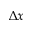<formula> <loc_0><loc_0><loc_500><loc_500>\Delta x</formula> 